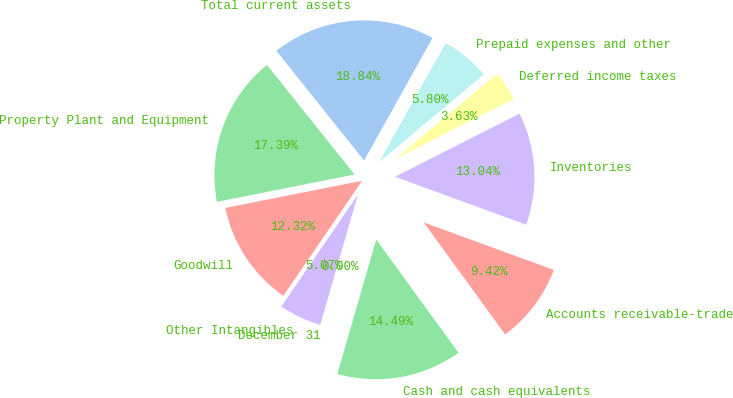Convert chart to OTSL. <chart><loc_0><loc_0><loc_500><loc_500><pie_chart><fcel>December 31<fcel>Cash and cash equivalents<fcel>Accounts receivable-trade<fcel>Inventories<fcel>Deferred income taxes<fcel>Prepaid expenses and other<fcel>Total current assets<fcel>Property Plant and Equipment<fcel>Goodwill<fcel>Other Intangibles<nl><fcel>0.0%<fcel>14.49%<fcel>9.42%<fcel>13.04%<fcel>3.63%<fcel>5.8%<fcel>18.84%<fcel>17.39%<fcel>12.32%<fcel>5.07%<nl></chart> 